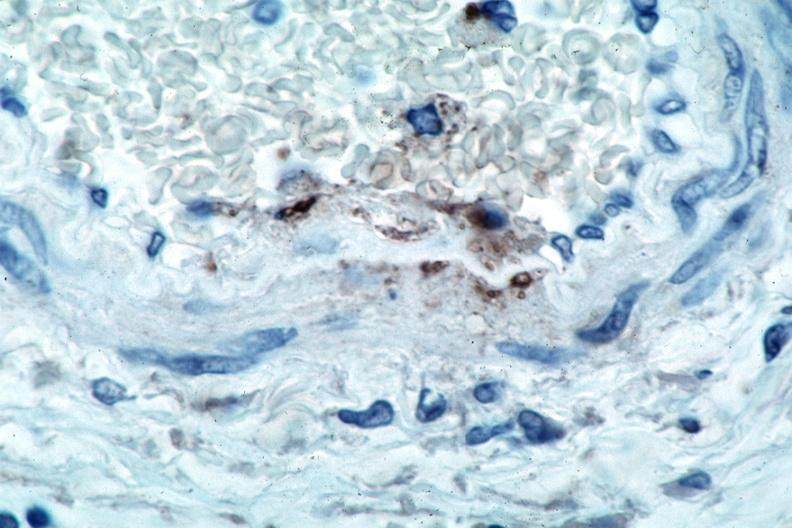does cranial artery show vasculitis?
Answer the question using a single word or phrase. No 